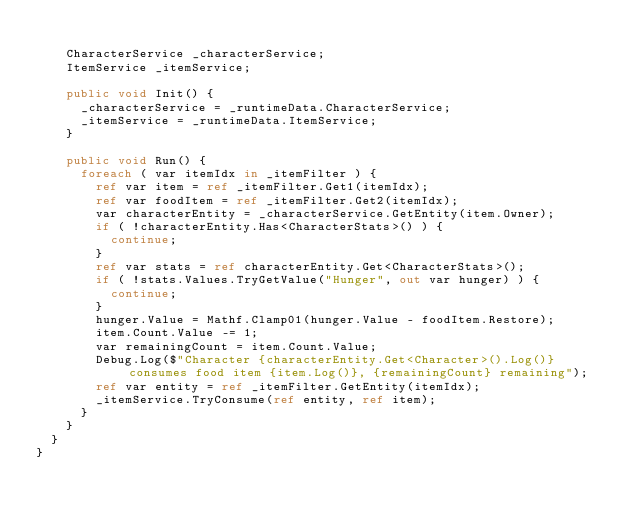<code> <loc_0><loc_0><loc_500><loc_500><_C#_>
		CharacterService _characterService;
		ItemService _itemService;

		public void Init() {
			_characterService = _runtimeData.CharacterService;
			_itemService = _runtimeData.ItemService;
		}

		public void Run() {
			foreach ( var itemIdx in _itemFilter ) {
				ref var item = ref _itemFilter.Get1(itemIdx);
				ref var foodItem = ref _itemFilter.Get2(itemIdx);
				var characterEntity = _characterService.GetEntity(item.Owner);
				if ( !characterEntity.Has<CharacterStats>() ) {
					continue;
				}
				ref var stats = ref characterEntity.Get<CharacterStats>();
				if ( !stats.Values.TryGetValue("Hunger", out var hunger) ) {
					continue;
				}
				hunger.Value = Mathf.Clamp01(hunger.Value - foodItem.Restore);
				item.Count.Value -= 1;
				var remainingCount = item.Count.Value;
				Debug.Log($"Character {characterEntity.Get<Character>().Log()} consumes food item {item.Log()}, {remainingCount} remaining");
				ref var entity = ref _itemFilter.GetEntity(itemIdx);
				_itemService.TryConsume(ref entity, ref item);
			}
		}
	}
}</code> 